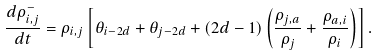Convert formula to latex. <formula><loc_0><loc_0><loc_500><loc_500>\frac { d \rho _ { i , j } ^ { - } } { d t } = \rho _ { i , j } \left [ \theta _ { i - 2 d } + \theta _ { j - 2 d } + ( 2 d - 1 ) \left ( \frac { \rho _ { j , a } } { \rho _ { j } } + \frac { \rho _ { a , i } } { \rho _ { i } } \right ) \right ] .</formula> 